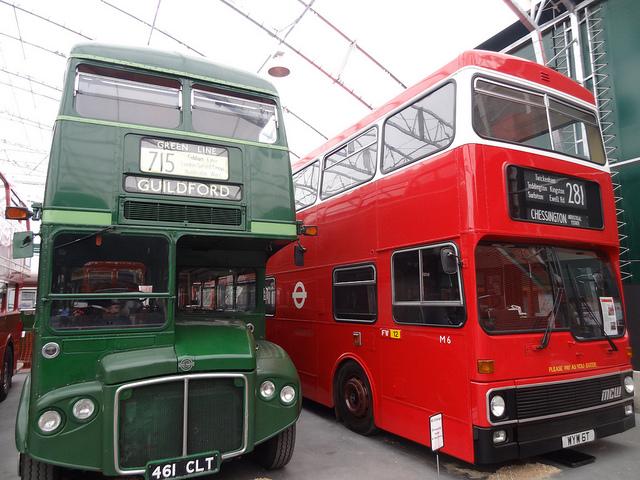What number is on the green bus sign?
Write a very short answer. 715. Where is the red bus?
Short answer required. Right. How many buses are in the picture?
Short answer required. 2. How many buses are parked side by side?
Concise answer only. 2. Does this bus support gay marriage?
Answer briefly. No. 